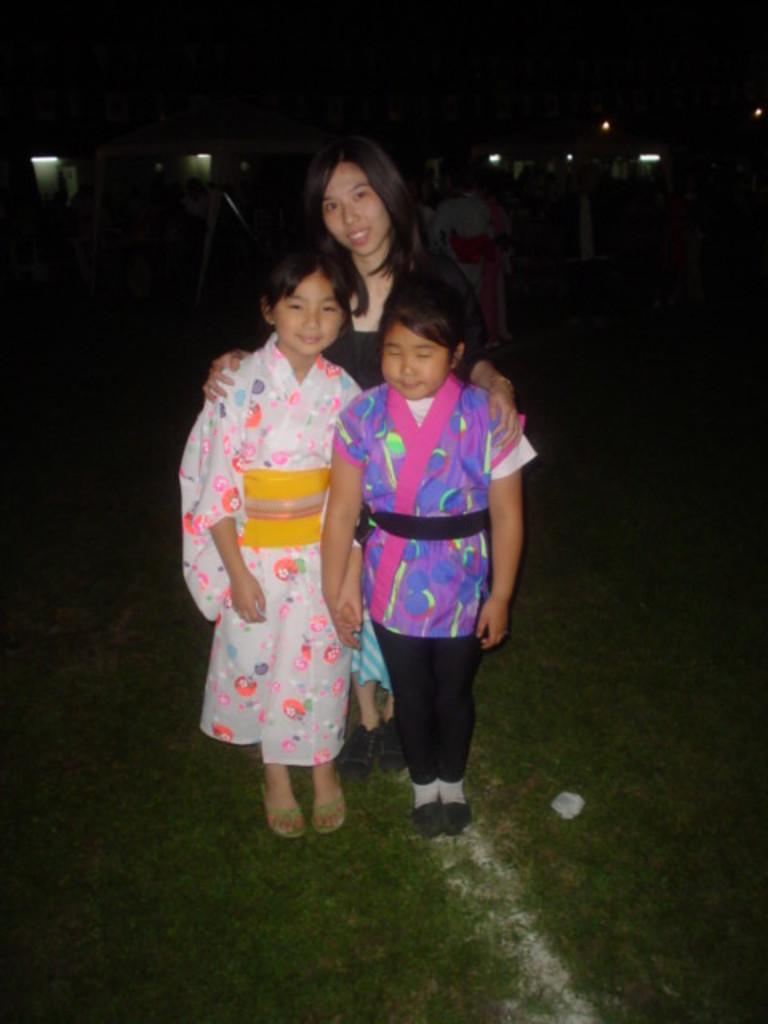How many people are standing in the foreground of the image? There are three persons standing in the foreground. What is the location of these people? They are standing on a road. What can be seen in the background of the image? There is a crowd and at least one building in the background, along with visible lights. Can you determine the time of day the image was taken? The image may have been taken during the night, as indicated by the presence of lights and the absence of sunlight. What type of bean is being used as a prop by one of the persons in the image? There is no bean present in the image, and no person is using a bean as a prop. 